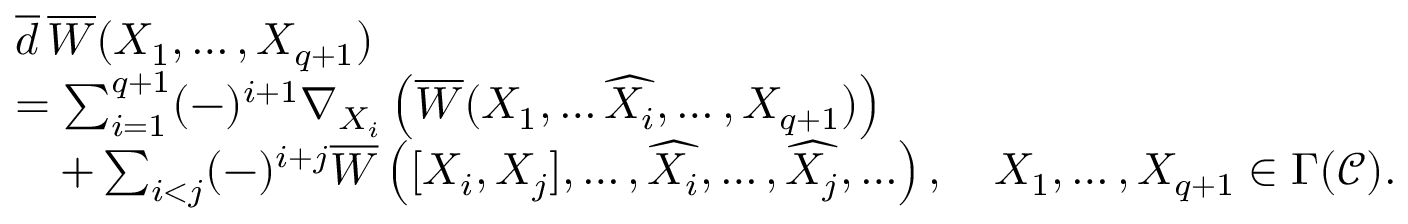<formula> <loc_0><loc_0><loc_500><loc_500>\begin{array} { r l } & { \overline { d } \, \overline { W } ( X _ { 1 } , \dots , X _ { q + 1 } ) } \\ & { = \sum _ { i = 1 } ^ { q + 1 } ( - ) ^ { i + 1 } \nabla _ { X _ { i } } \left ( \overline { W } ( X _ { 1 } , \dots \widehat { X _ { i } } , \dots , X _ { q + 1 } ) \right ) } \\ & { \quad + \sum _ { i < j } ( - ) ^ { i + j } \overline { W } \left ( [ X _ { i } , X _ { j } ] , \dots , \widehat { X _ { i } } , \dots , \widehat { X _ { j } } , \dots \right ) , \quad X _ { 1 } , \dots , X _ { q + 1 } \in \Gamma ( \ m a t h s c r C ) . } \end{array}</formula> 